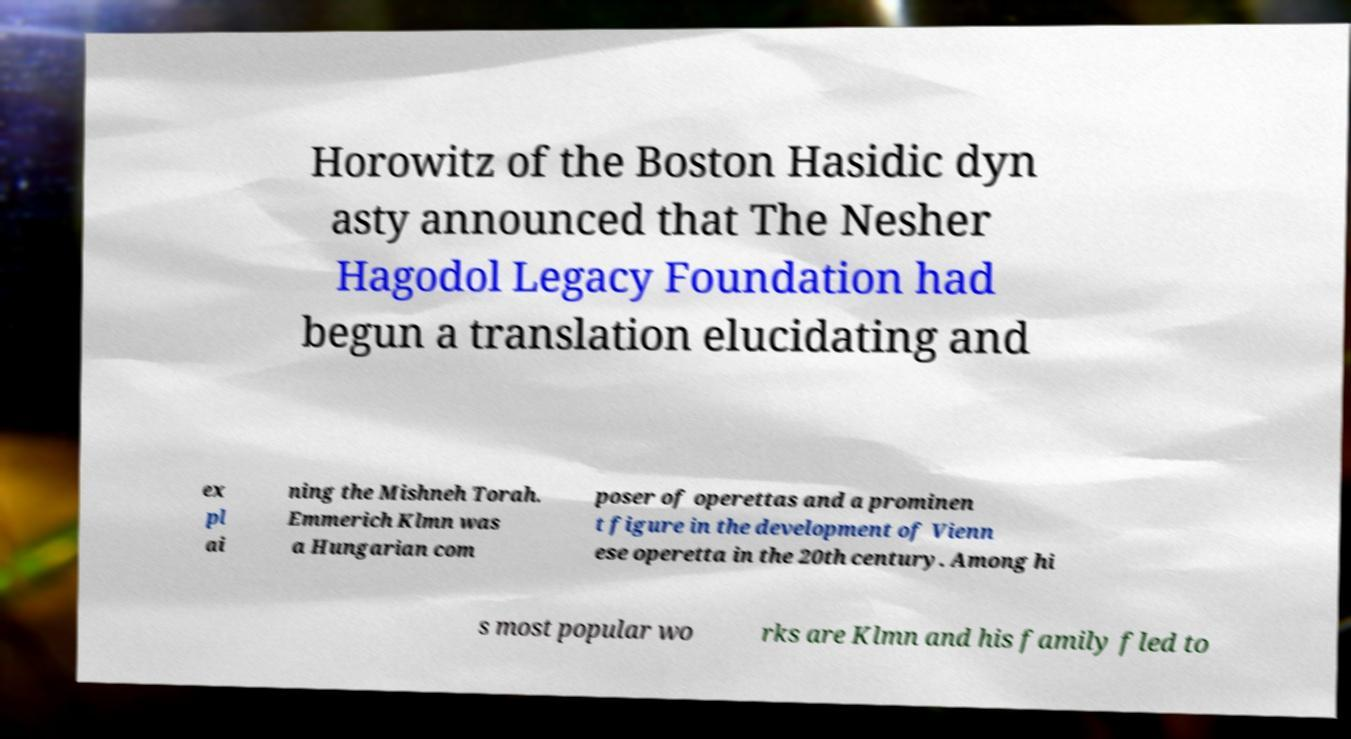Could you assist in decoding the text presented in this image and type it out clearly? Horowitz of the Boston Hasidic dyn asty announced that The Nesher Hagodol Legacy Foundation had begun a translation elucidating and ex pl ai ning the Mishneh Torah. Emmerich Klmn was a Hungarian com poser of operettas and a prominen t figure in the development of Vienn ese operetta in the 20th century. Among hi s most popular wo rks are Klmn and his family fled to 